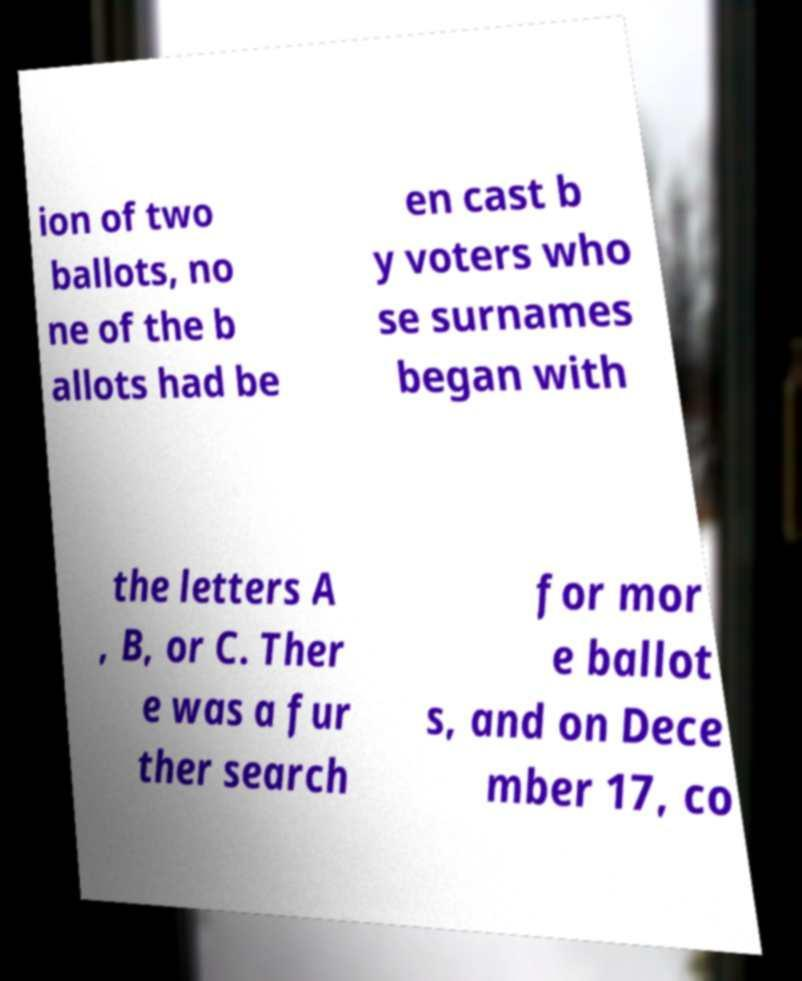What messages or text are displayed in this image? I need them in a readable, typed format. ion of two ballots, no ne of the b allots had be en cast b y voters who se surnames began with the letters A , B, or C. Ther e was a fur ther search for mor e ballot s, and on Dece mber 17, co 